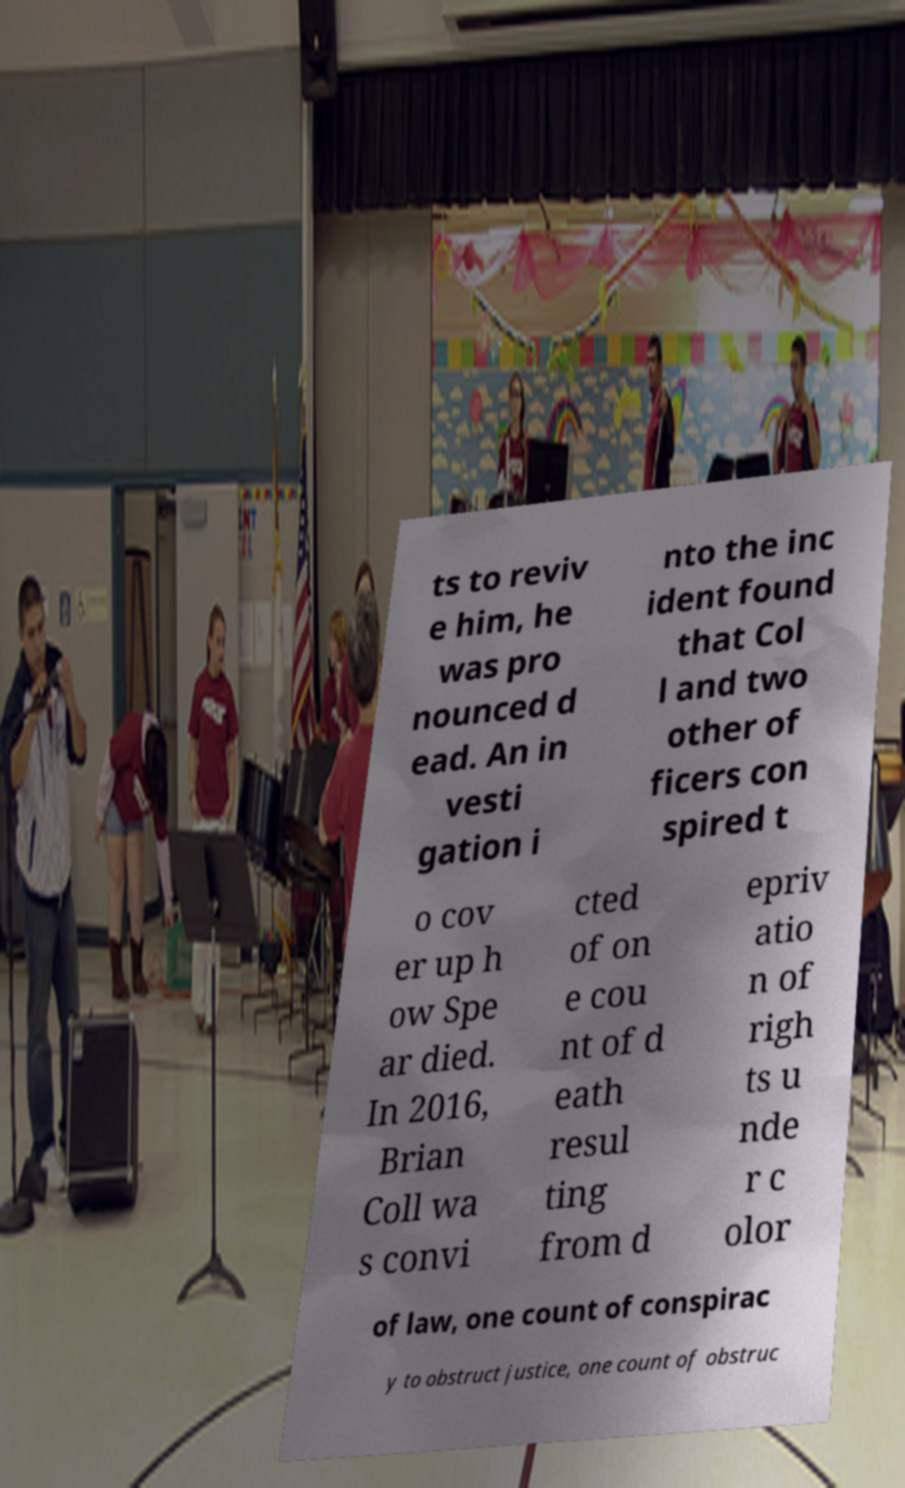I need the written content from this picture converted into text. Can you do that? ts to reviv e him, he was pro nounced d ead. An in vesti gation i nto the inc ident found that Col l and two other of ficers con spired t o cov er up h ow Spe ar died. In 2016, Brian Coll wa s convi cted of on e cou nt of d eath resul ting from d epriv atio n of righ ts u nde r c olor of law, one count of conspirac y to obstruct justice, one count of obstruc 